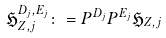<formula> <loc_0><loc_0><loc_500><loc_500>\mathfrak { H } _ { Z , j } ^ { D _ { j } , E _ { j } } \colon = P ^ { D _ { j } } P ^ { E _ { j } } \mathfrak { H } _ { Z , j }</formula> 